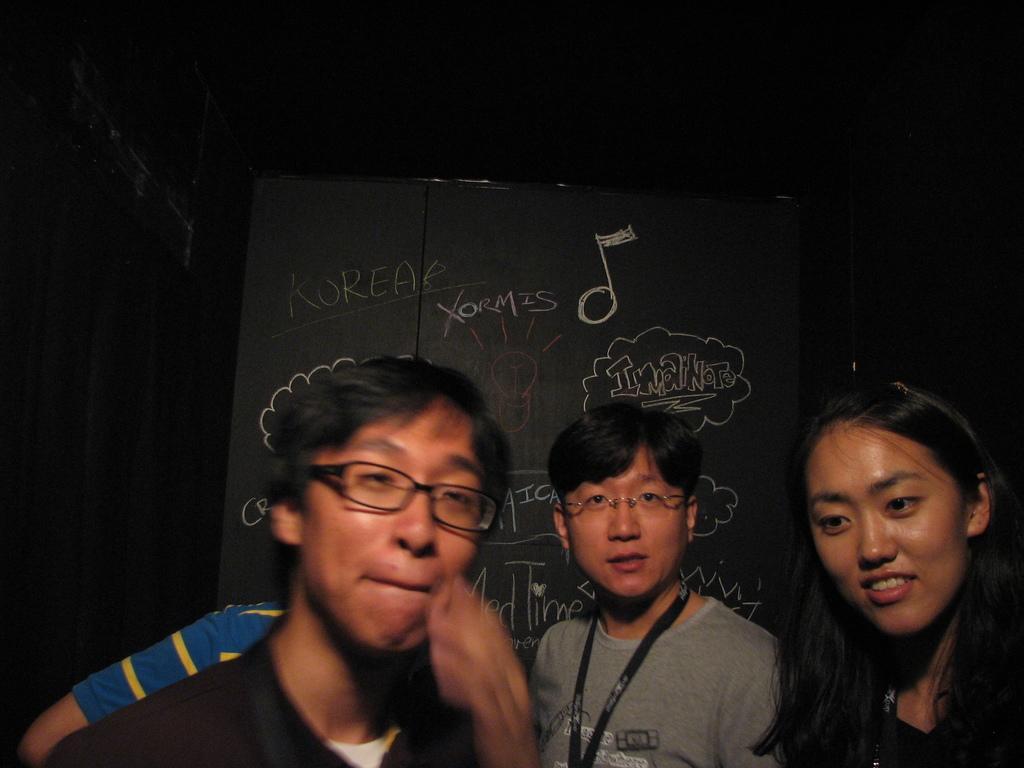Could you give a brief overview of what you see in this image? In this picture there is a man who is wearing spectacle and t-shirt. Beside him there is a girl who is wearing black dress. On the left I can see a person's shoulder who is standing near to the blackboard. In front of him there is a man who is wearing spectacle and t-shirt. At the top I can see the darkness. 